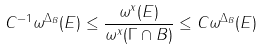Convert formula to latex. <formula><loc_0><loc_0><loc_500><loc_500>C ^ { - 1 } \omega ^ { \Delta _ { B } } ( E ) \leq \frac { \omega ^ { x } ( E ) } { \omega ^ { x } ( \Gamma \cap B ) } \leq C \omega ^ { \Delta _ { B } } ( E )</formula> 